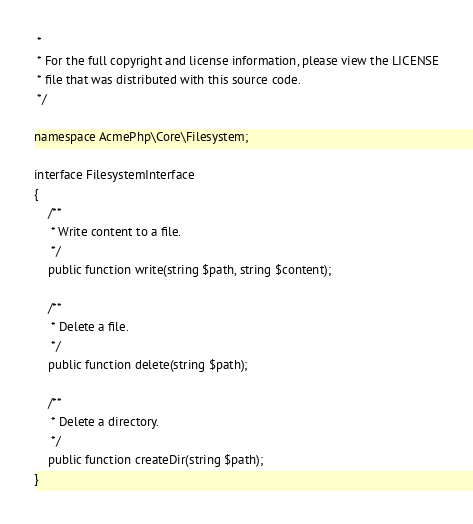<code> <loc_0><loc_0><loc_500><loc_500><_PHP_> *
 * For the full copyright and license information, please view the LICENSE
 * file that was distributed with this source code.
 */

namespace AcmePhp\Core\Filesystem;

interface FilesystemInterface
{
    /**
     * Write content to a file.
     */
    public function write(string $path, string $content);

    /**
     * Delete a file.
     */
    public function delete(string $path);

    /**
     * Delete a directory.
     */
    public function createDir(string $path);
}
</code> 